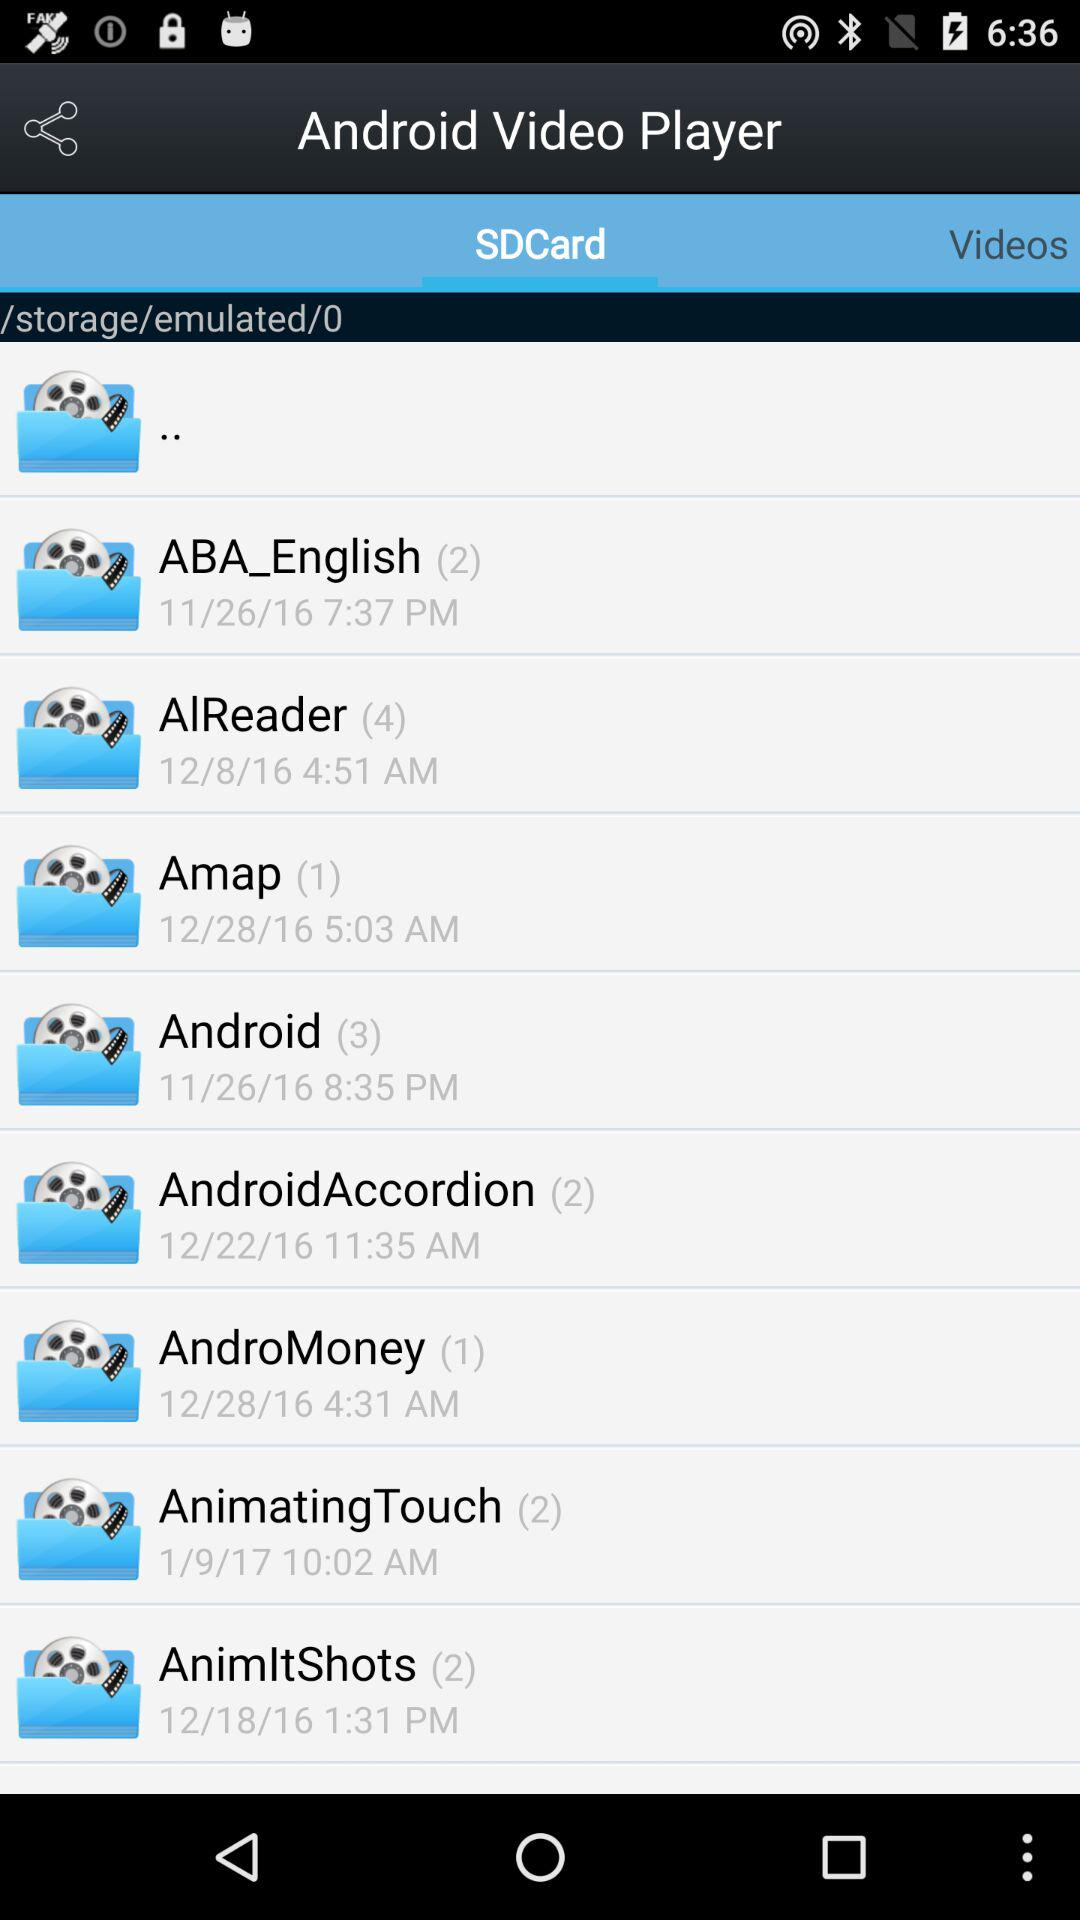Which folder has three subfolders? The folder that has 3 subfolders is "Android". 